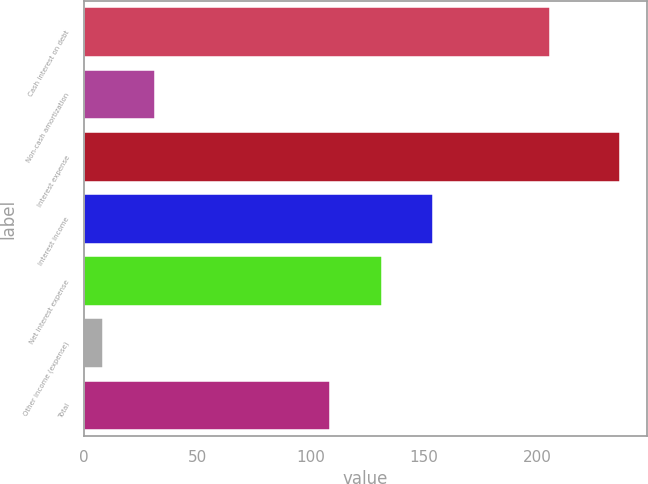<chart> <loc_0><loc_0><loc_500><loc_500><bar_chart><fcel>Cash interest on debt<fcel>Non-cash amortization<fcel>Interest expense<fcel>Interest income<fcel>Net interest expense<fcel>Other income (expense)<fcel>Total<nl><fcel>205.9<fcel>31.32<fcel>236.7<fcel>154.24<fcel>131.42<fcel>8.5<fcel>108.6<nl></chart> 